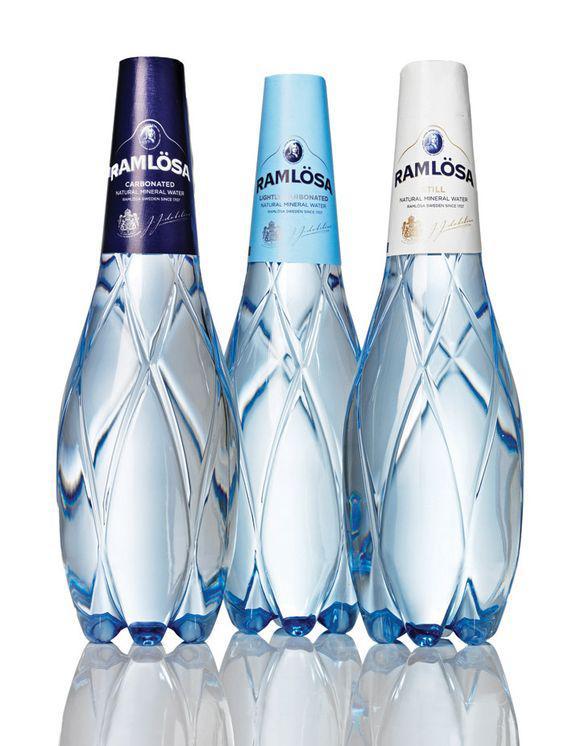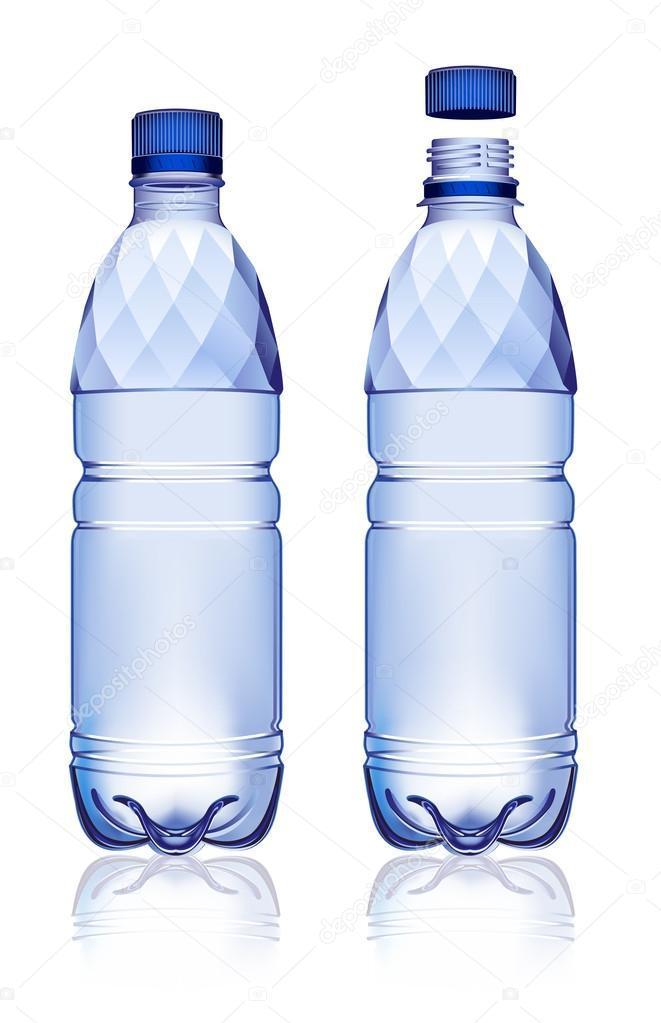The first image is the image on the left, the second image is the image on the right. For the images displayed, is the sentence "An image shows exactly two lidded, unlabeled water bottles of the same size and shape, displayed level and side-by-side." factually correct? Answer yes or no. No. The first image is the image on the left, the second image is the image on the right. Considering the images on both sides, is "There are five bottles in total." valid? Answer yes or no. Yes. 